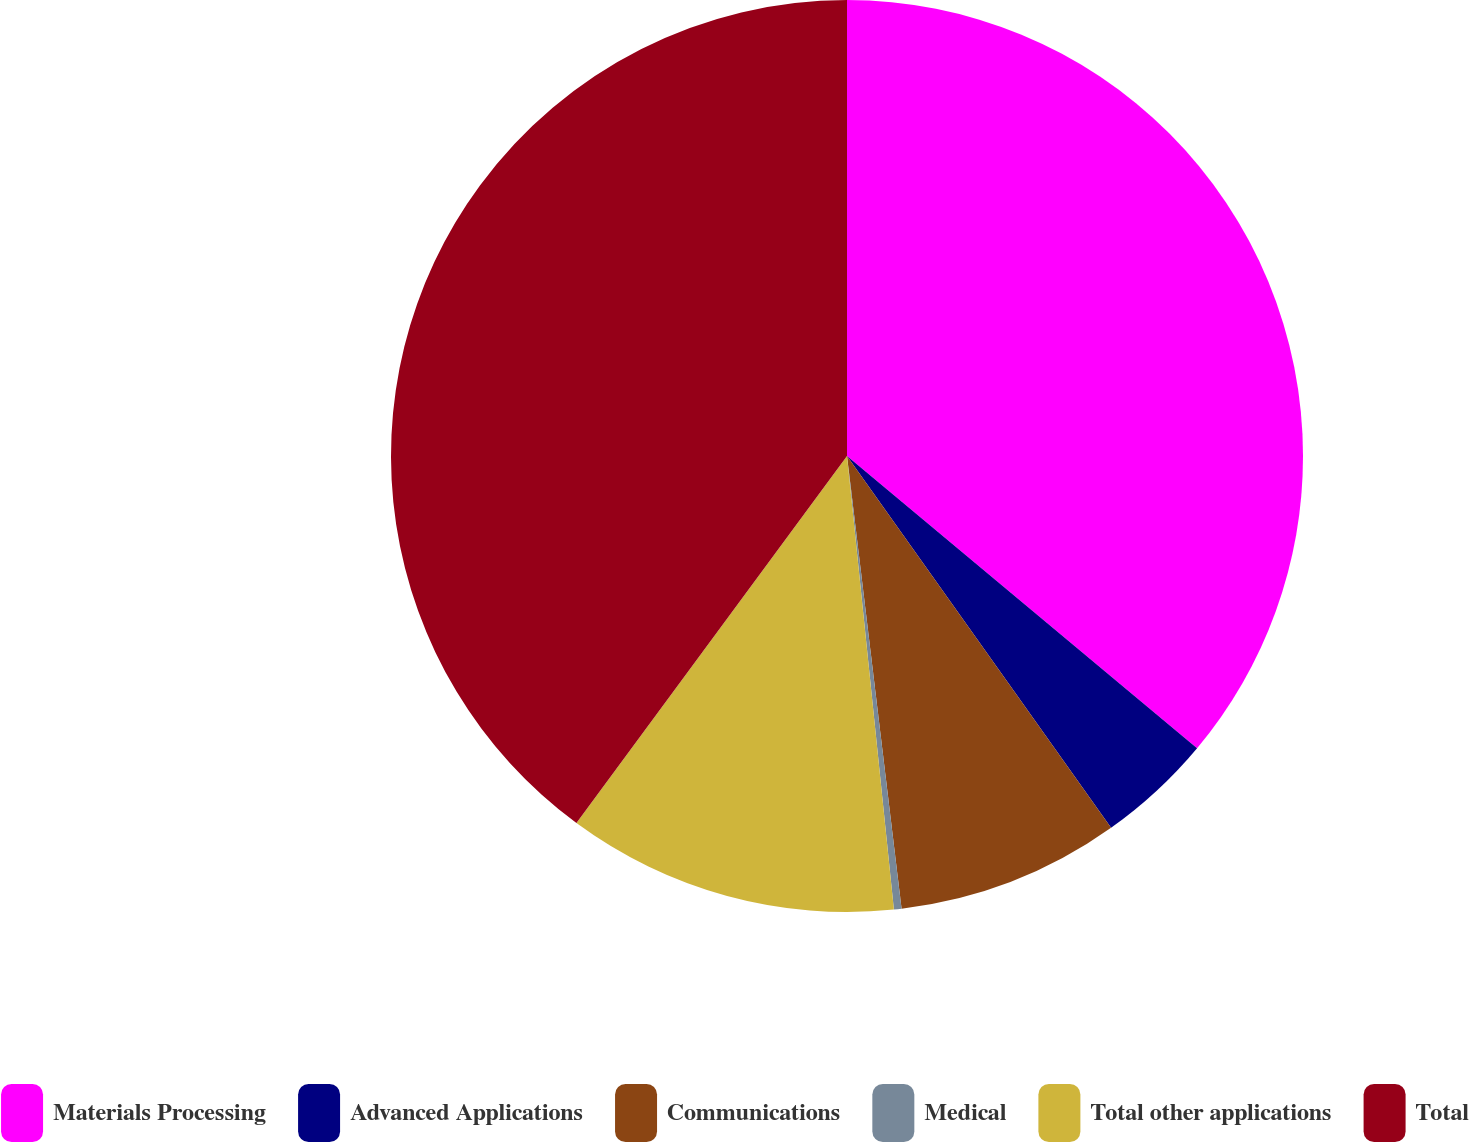Convert chart. <chart><loc_0><loc_0><loc_500><loc_500><pie_chart><fcel>Materials Processing<fcel>Advanced Applications<fcel>Communications<fcel>Medical<fcel>Total other applications<fcel>Total<nl><fcel>36.07%<fcel>4.1%<fcel>7.92%<fcel>0.27%<fcel>11.75%<fcel>39.89%<nl></chart> 